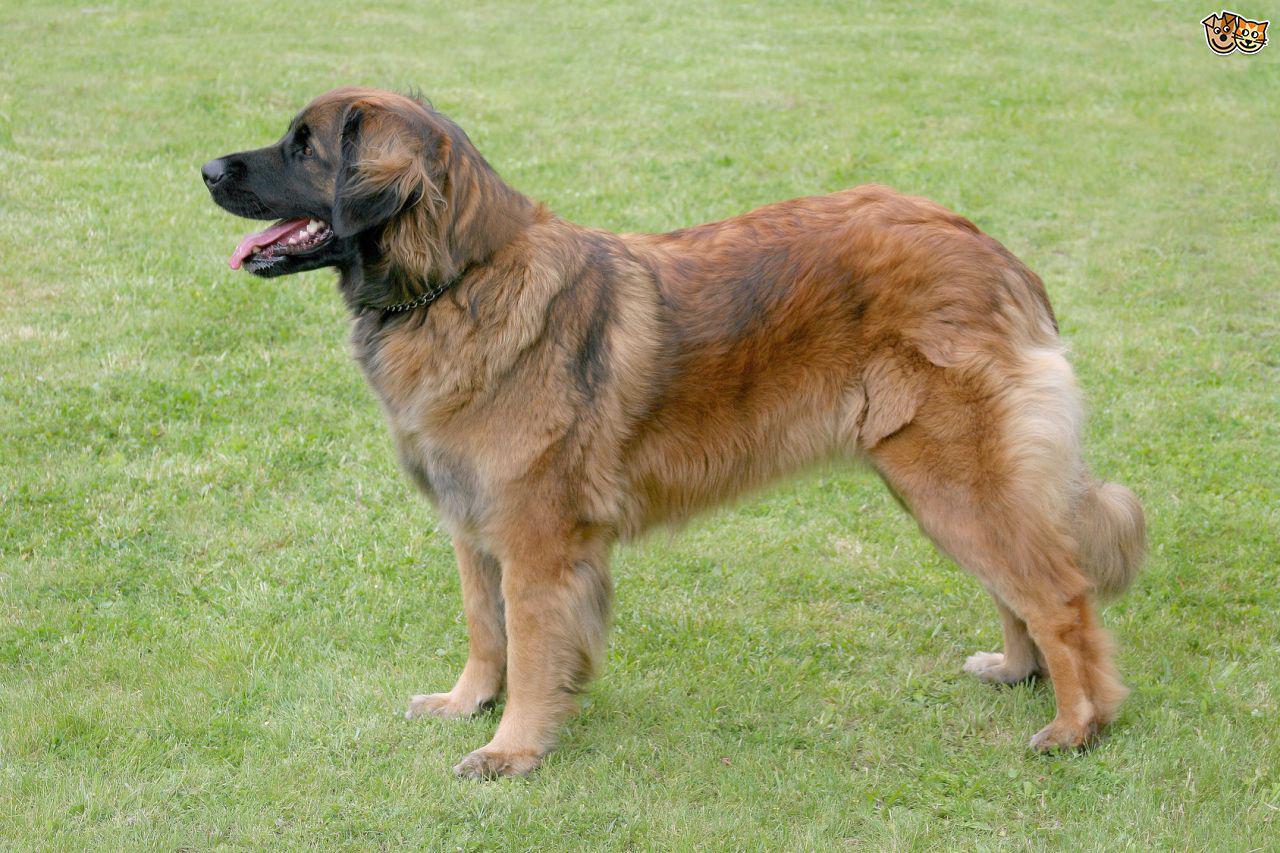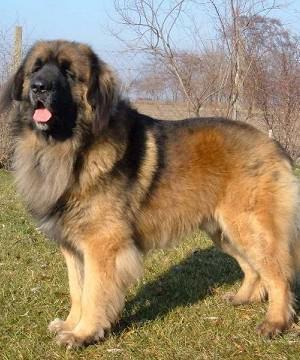The first image is the image on the left, the second image is the image on the right. Evaluate the accuracy of this statement regarding the images: "Each image contains exactly one dog, which is standing in profile.". Is it true? Answer yes or no. Yes. The first image is the image on the left, the second image is the image on the right. Evaluate the accuracy of this statement regarding the images: "There are at least three dogs  outside.". Is it true? Answer yes or no. No. 